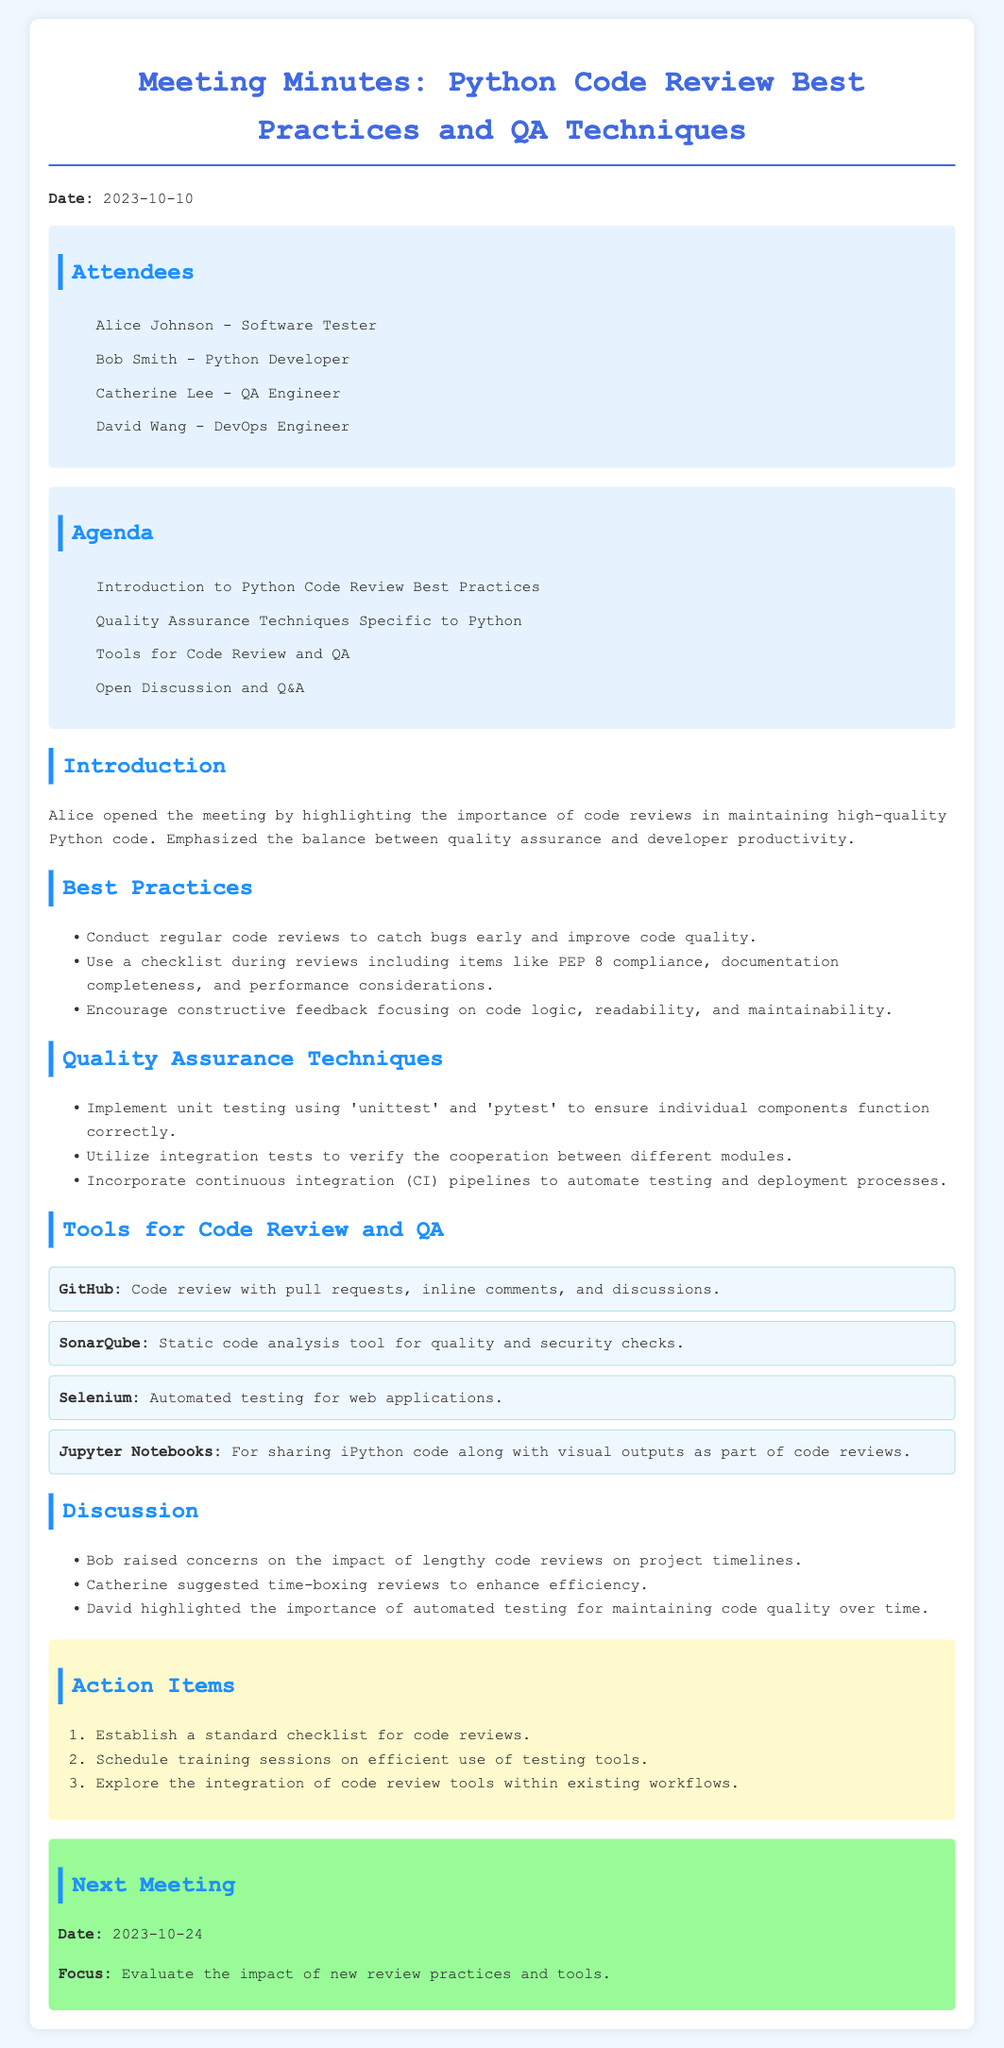What date was the meeting held? The meeting date is specified in the document as "2023-10-10."
Answer: 2023-10-10 Who emphasized the importance of code reviews? The document states that Alice opened the meeting and highlighted the importance of code reviews.
Answer: Alice What tools were mentioned for code review? The document lists several tools, including GitHub, SonarQube, Selenium, and Jupyter Notebooks.
Answer: GitHub, SonarQube, Selenium, Jupyter Notebooks How many action items were listed in the minutes? The document outlines three action items under the Action Items section.
Answer: 3 What is one suggested technique for quality assurance? The document mentions implementing unit testing using 'unittest' and 'pytest.'
Answer: Unit testing Who raised concerns about the impact of lengthy code reviews? Bob is noted in the document as raising concerns regarding lengthy code reviews.
Answer: Bob When is the next meeting scheduled? The document specifies the next meeting as happening on "2023-10-24."
Answer: 2023-10-24 What is the focus of the next meeting? The document indicates that the focus will be to evaluate the impact of new review practices and tools.
Answer: Evaluate the impact of new review practices and tools What did Catherine suggest to enhance review efficiency? According to the document, Catherine suggested time-boxing reviews.
Answer: Time-boxing reviews 